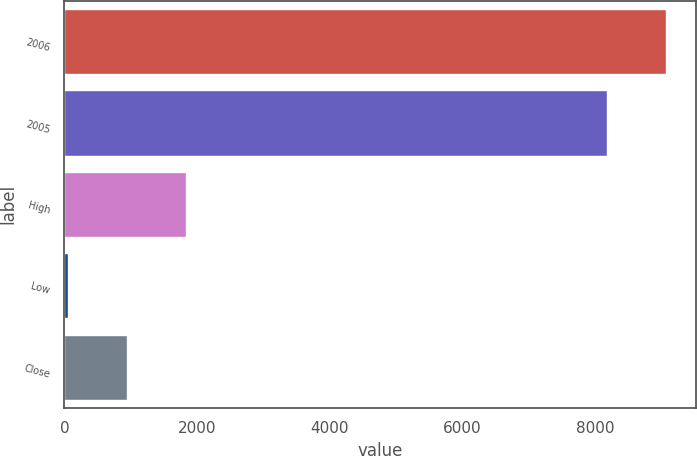Convert chart. <chart><loc_0><loc_0><loc_500><loc_500><bar_chart><fcel>2006<fcel>2005<fcel>High<fcel>Low<fcel>Close<nl><fcel>9073.14<fcel>8184<fcel>1836.93<fcel>58.65<fcel>947.79<nl></chart> 